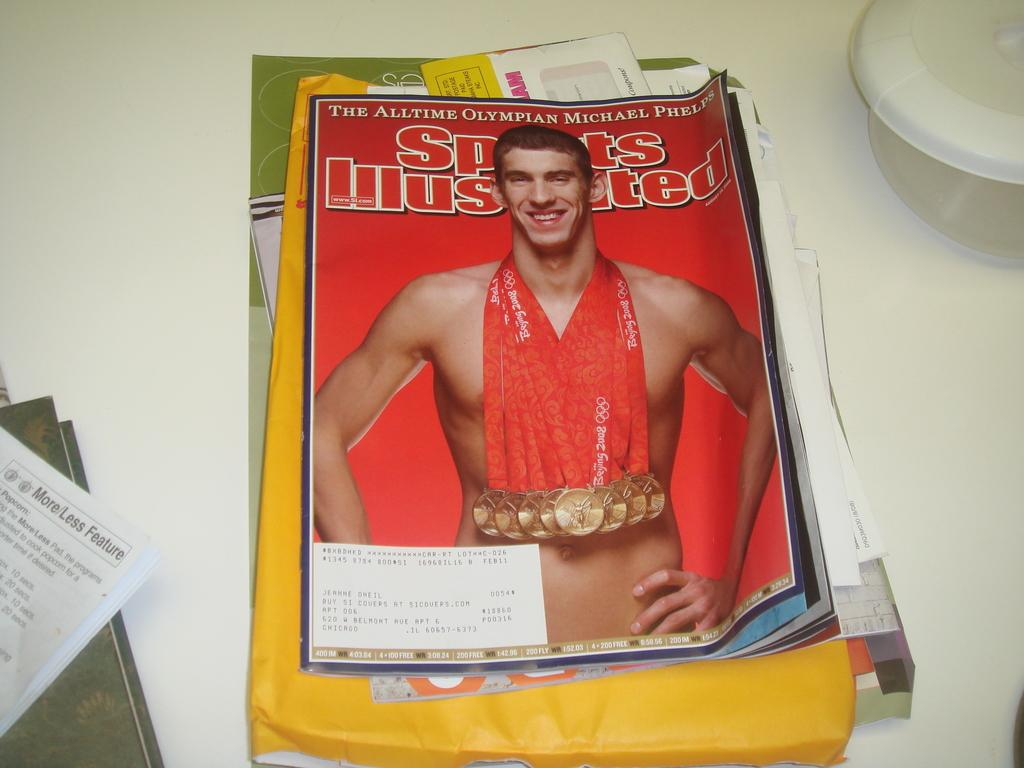What type of reading material is present in the image? There is a magazine in the image. What else can be seen on the white surface? There are papers in the image. What is the color of the surface on which the objects are placed? The objects are on a white surface. Can you describe the content of the magazine? There is writing in the magazine. What is written on the papers? There is writing on the papers. How many sheep are visible in the image? There are no sheep present in the image. What type of polish is being applied to the papers in the image? There is no polish or any indication of polishing in the image. 